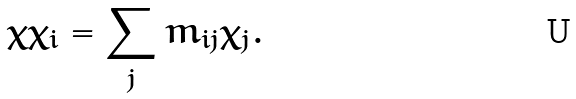<formula> <loc_0><loc_0><loc_500><loc_500>\chi \chi _ { i } = \sum _ { j } m _ { i j } \chi _ { j } .</formula> 